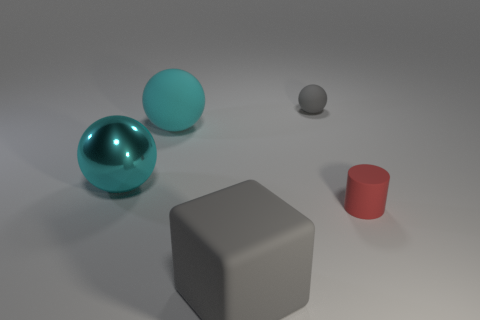Add 4 yellow metallic spheres. How many objects exist? 9 Subtract all balls. How many objects are left? 2 Subtract all tiny red objects. Subtract all big cyan matte balls. How many objects are left? 3 Add 2 big gray rubber blocks. How many big gray rubber blocks are left? 3 Add 2 tiny red cylinders. How many tiny red cylinders exist? 3 Subtract 0 yellow blocks. How many objects are left? 5 